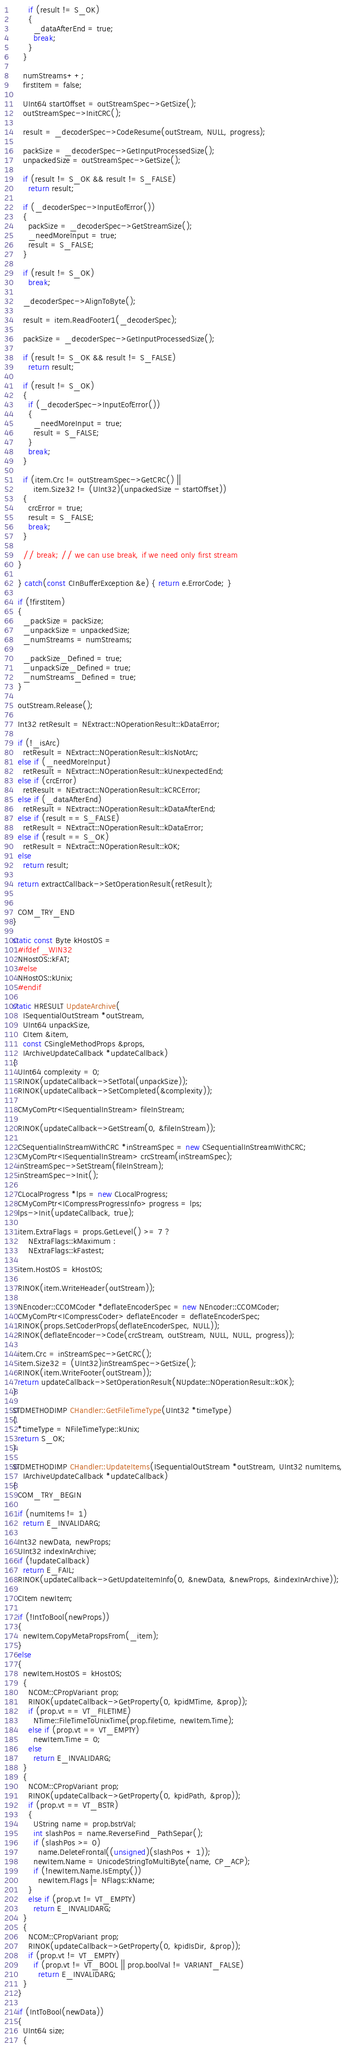Convert code to text. <code><loc_0><loc_0><loc_500><loc_500><_C++_>
      if (result != S_OK)
      {
        _dataAfterEnd = true;
        break;
      }
    }
    
    numStreams++;
    firstItem = false;

    UInt64 startOffset = outStreamSpec->GetSize();
    outStreamSpec->InitCRC();

    result = _decoderSpec->CodeResume(outStream, NULL, progress);

    packSize = _decoderSpec->GetInputProcessedSize();
    unpackedSize = outStreamSpec->GetSize();

    if (result != S_OK && result != S_FALSE)
      return result;

    if (_decoderSpec->InputEofError())
    {
      packSize = _decoderSpec->GetStreamSize();
      _needMoreInput = true;
      result = S_FALSE;
    }

    if (result != S_OK)
      break;

    _decoderSpec->AlignToByte();
    
    result = item.ReadFooter1(_decoderSpec);

    packSize = _decoderSpec->GetInputProcessedSize();

    if (result != S_OK && result != S_FALSE)
      return result;

    if (result != S_OK)
    {
      if (_decoderSpec->InputEofError())
      {
        _needMoreInput = true;
        result = S_FALSE;
      }
      break;
    }

    if (item.Crc != outStreamSpec->GetCRC() ||
        item.Size32 != (UInt32)(unpackedSize - startOffset))
    {
      crcError = true;
      result = S_FALSE;
      break;
    }

    // break; // we can use break, if we need only first stream
  }

  } catch(const CInBufferException &e) { return e.ErrorCode; }

  if (!firstItem)
  {
    _packSize = packSize;
    _unpackSize = unpackedSize;
    _numStreams = numStreams;

    _packSize_Defined = true;
    _unpackSize_Defined = true;
    _numStreams_Defined = true;
  }

  outStream.Release();

  Int32 retResult = NExtract::NOperationResult::kDataError;

  if (!_isArc)
    retResult = NExtract::NOperationResult::kIsNotArc;
  else if (_needMoreInput)
    retResult = NExtract::NOperationResult::kUnexpectedEnd;
  else if (crcError)
    retResult = NExtract::NOperationResult::kCRCError;
  else if (_dataAfterEnd)
    retResult = NExtract::NOperationResult::kDataAfterEnd;
  else if (result == S_FALSE)
    retResult = NExtract::NOperationResult::kDataError;
  else if (result == S_OK)
    retResult = NExtract::NOperationResult::kOK;
  else
    return result;

  return extractCallback->SetOperationResult(retResult);


  COM_TRY_END
}

static const Byte kHostOS =
  #ifdef _WIN32
  NHostOS::kFAT;
  #else
  NHostOS::kUnix;
  #endif

static HRESULT UpdateArchive(
    ISequentialOutStream *outStream,
    UInt64 unpackSize,
    CItem &item,
    const CSingleMethodProps &props,
    IArchiveUpdateCallback *updateCallback)
{
  UInt64 complexity = 0;
  RINOK(updateCallback->SetTotal(unpackSize));
  RINOK(updateCallback->SetCompleted(&complexity));

  CMyComPtr<ISequentialInStream> fileInStream;

  RINOK(updateCallback->GetStream(0, &fileInStream));

  CSequentialInStreamWithCRC *inStreamSpec = new CSequentialInStreamWithCRC;
  CMyComPtr<ISequentialInStream> crcStream(inStreamSpec);
  inStreamSpec->SetStream(fileInStream);
  inStreamSpec->Init();

  CLocalProgress *lps = new CLocalProgress;
  CMyComPtr<ICompressProgressInfo> progress = lps;
  lps->Init(updateCallback, true);
  
  item.ExtraFlags = props.GetLevel() >= 7 ?
      NExtraFlags::kMaximum :
      NExtraFlags::kFastest;

  item.HostOS = kHostOS;

  RINOK(item.WriteHeader(outStream));

  NEncoder::CCOMCoder *deflateEncoderSpec = new NEncoder::CCOMCoder;
  CMyComPtr<ICompressCoder> deflateEncoder = deflateEncoderSpec;
  RINOK(props.SetCoderProps(deflateEncoderSpec, NULL));
  RINOK(deflateEncoder->Code(crcStream, outStream, NULL, NULL, progress));

  item.Crc = inStreamSpec->GetCRC();
  item.Size32 = (UInt32)inStreamSpec->GetSize();
  RINOK(item.WriteFooter(outStream));
  return updateCallback->SetOperationResult(NUpdate::NOperationResult::kOK);
}

STDMETHODIMP CHandler::GetFileTimeType(UInt32 *timeType)
{
  *timeType = NFileTimeType::kUnix;
  return S_OK;
}

STDMETHODIMP CHandler::UpdateItems(ISequentialOutStream *outStream, UInt32 numItems,
    IArchiveUpdateCallback *updateCallback)
{
  COM_TRY_BEGIN

  if (numItems != 1)
    return E_INVALIDARG;

  Int32 newData, newProps;
  UInt32 indexInArchive;
  if (!updateCallback)
    return E_FAIL;
  RINOK(updateCallback->GetUpdateItemInfo(0, &newData, &newProps, &indexInArchive));

  CItem newItem;
  
  if (!IntToBool(newProps))
  {
    newItem.CopyMetaPropsFrom(_item);
  }
  else
  {
    newItem.HostOS = kHostOS;
    {
      NCOM::CPropVariant prop;
      RINOK(updateCallback->GetProperty(0, kpidMTime, &prop));
      if (prop.vt == VT_FILETIME)
        NTime::FileTimeToUnixTime(prop.filetime, newItem.Time);
      else if (prop.vt == VT_EMPTY)
        newItem.Time = 0;
      else
        return E_INVALIDARG;
    }
    {
      NCOM::CPropVariant prop;
      RINOK(updateCallback->GetProperty(0, kpidPath, &prop));
      if (prop.vt == VT_BSTR)
      {
        UString name = prop.bstrVal;
        int slashPos = name.ReverseFind_PathSepar();
        if (slashPos >= 0)
          name.DeleteFrontal((unsigned)(slashPos + 1));
        newItem.Name = UnicodeStringToMultiByte(name, CP_ACP);
        if (!newItem.Name.IsEmpty())
          newItem.Flags |= NFlags::kName;
      }
      else if (prop.vt != VT_EMPTY)
        return E_INVALIDARG;
    }
    {
      NCOM::CPropVariant prop;
      RINOK(updateCallback->GetProperty(0, kpidIsDir, &prop));
      if (prop.vt != VT_EMPTY)
        if (prop.vt != VT_BOOL || prop.boolVal != VARIANT_FALSE)
          return E_INVALIDARG;
    }
  }

  if (IntToBool(newData))
  {
    UInt64 size;
    {</code> 